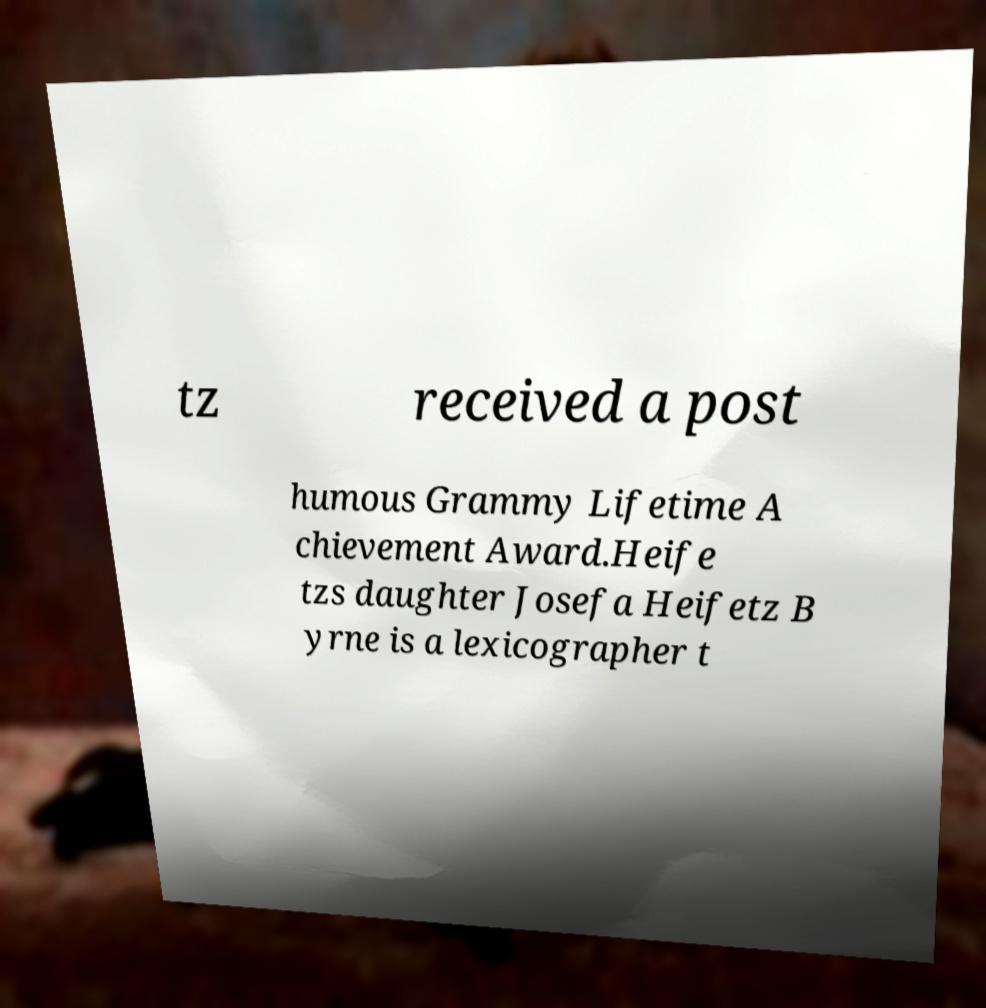There's text embedded in this image that I need extracted. Can you transcribe it verbatim? tz received a post humous Grammy Lifetime A chievement Award.Heife tzs daughter Josefa Heifetz B yrne is a lexicographer t 